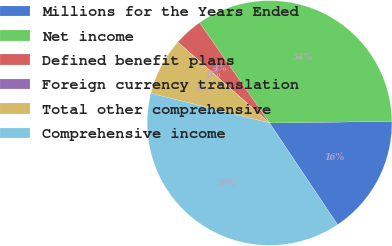<chart> <loc_0><loc_0><loc_500><loc_500><pie_chart><fcel>Millions for the Years Ended<fcel>Net income<fcel>Defined benefit plans<fcel>Foreign currency translation<fcel>Total other comprehensive<fcel>Comprehensive income<nl><fcel>15.82%<fcel>34.49%<fcel>3.8%<fcel>0.01%<fcel>7.59%<fcel>38.28%<nl></chart> 